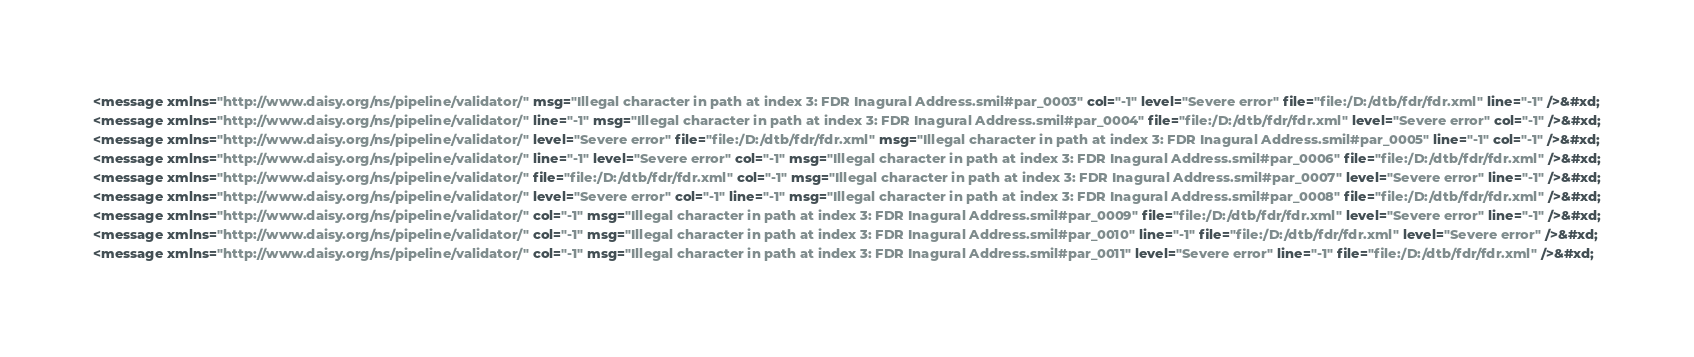Convert code to text. <code><loc_0><loc_0><loc_500><loc_500><_XML_><message xmlns="http://www.daisy.org/ns/pipeline/validator/" msg="Illegal character in path at index 3: FDR Inagural Address.smil#par_0003" col="-1" level="Severe error" file="file:/D:/dtb/fdr/fdr.xml" line="-1" />&#xd;
<message xmlns="http://www.daisy.org/ns/pipeline/validator/" line="-1" msg="Illegal character in path at index 3: FDR Inagural Address.smil#par_0004" file="file:/D:/dtb/fdr/fdr.xml" level="Severe error" col="-1" />&#xd;
<message xmlns="http://www.daisy.org/ns/pipeline/validator/" level="Severe error" file="file:/D:/dtb/fdr/fdr.xml" msg="Illegal character in path at index 3: FDR Inagural Address.smil#par_0005" line="-1" col="-1" />&#xd;
<message xmlns="http://www.daisy.org/ns/pipeline/validator/" line="-1" level="Severe error" col="-1" msg="Illegal character in path at index 3: FDR Inagural Address.smil#par_0006" file="file:/D:/dtb/fdr/fdr.xml" />&#xd;
<message xmlns="http://www.daisy.org/ns/pipeline/validator/" file="file:/D:/dtb/fdr/fdr.xml" col="-1" msg="Illegal character in path at index 3: FDR Inagural Address.smil#par_0007" level="Severe error" line="-1" />&#xd;
<message xmlns="http://www.daisy.org/ns/pipeline/validator/" level="Severe error" col="-1" line="-1" msg="Illegal character in path at index 3: FDR Inagural Address.smil#par_0008" file="file:/D:/dtb/fdr/fdr.xml" />&#xd;
<message xmlns="http://www.daisy.org/ns/pipeline/validator/" col="-1" msg="Illegal character in path at index 3: FDR Inagural Address.smil#par_0009" file="file:/D:/dtb/fdr/fdr.xml" level="Severe error" line="-1" />&#xd;
<message xmlns="http://www.daisy.org/ns/pipeline/validator/" col="-1" msg="Illegal character in path at index 3: FDR Inagural Address.smil#par_0010" line="-1" file="file:/D:/dtb/fdr/fdr.xml" level="Severe error" />&#xd;
<message xmlns="http://www.daisy.org/ns/pipeline/validator/" col="-1" msg="Illegal character in path at index 3: FDR Inagural Address.smil#par_0011" level="Severe error" line="-1" file="file:/D:/dtb/fdr/fdr.xml" />&#xd;</code> 